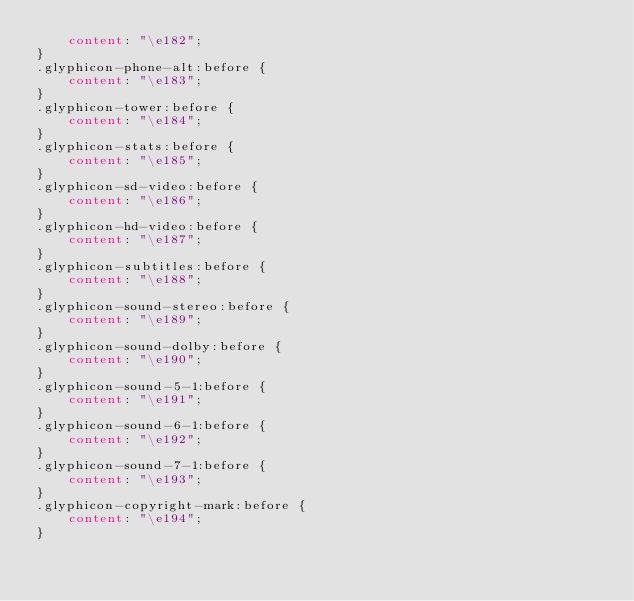Convert code to text. <code><loc_0><loc_0><loc_500><loc_500><_CSS_>    content: "\e182";
}
.glyphicon-phone-alt:before {
    content: "\e183";
}
.glyphicon-tower:before {
    content: "\e184";
}
.glyphicon-stats:before {
    content: "\e185";
}
.glyphicon-sd-video:before {
    content: "\e186";
}
.glyphicon-hd-video:before {
    content: "\e187";
}
.glyphicon-subtitles:before {
    content: "\e188";
}
.glyphicon-sound-stereo:before {
    content: "\e189";
}
.glyphicon-sound-dolby:before {
    content: "\e190";
}
.glyphicon-sound-5-1:before {
    content: "\e191";
}
.glyphicon-sound-6-1:before {
    content: "\e192";
}
.glyphicon-sound-7-1:before {
    content: "\e193";
}
.glyphicon-copyright-mark:before {
    content: "\e194";
}</code> 